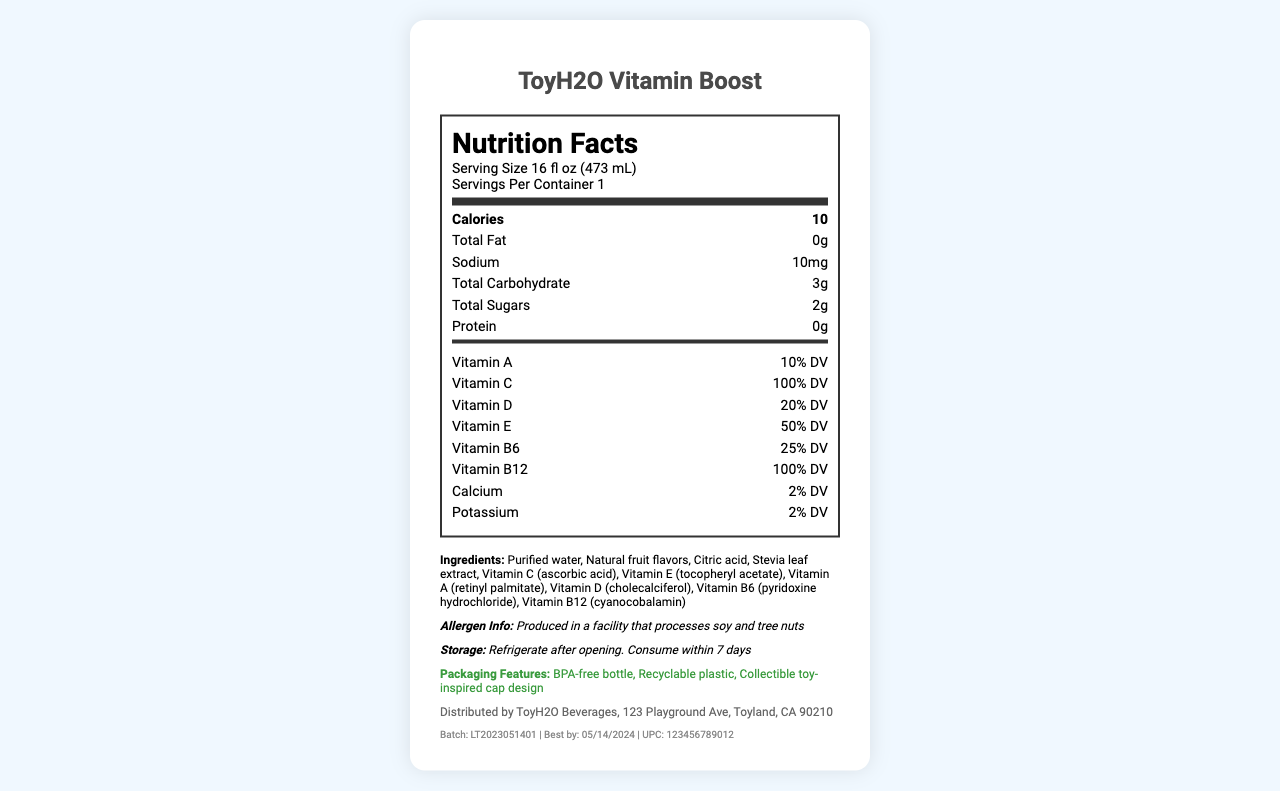What is the serving size of ToyH2O Vitamin Boost? The serving size is explicitly stated as "16 fl oz (473 mL)" under the nutrition facts title.
Answer: 16 fl oz (473 mL) How many calories are there per serving? The nutrition label indicates "Calories 10" for each serving.
Answer: 10 What vitamins and their daily values are included in this water bottle? The vitamins and daily values are listed under the vitamins section of the nutrition label.
Answer: Vitamin A (10% DV), Vitamin C (100% DV), Vitamin D (20% DV), Vitamin E (50% DV), Vitamin B6 (25% DV), Vitamin B12 (100% DV) What should consumers do after opening the bottle? The storage instructions state, "Refrigerate after opening. Consume within 7 days."
Answer: Refrigerate after opening. Consume within 7 days. Is the bottle BPA-free? Under packaging features, it mentions "BPA-free bottle".
Answer: Yes How many grams of protein are there in ToyH2O Vitamin Boost? The nutrition label mentions "Protein 0g".
Answer: 0g Are there any allergens in this product? The allergen info states it is produced in a facility that processes soy and tree nuts, but it does not specify if the product itself contains allergens.
Answer: Cannot be determined Which ingredient is used as a sweetener in this product? A. Stevia leaf extract B. Sugar C. Aspartame D. Sucralose The ingredient list includes "Stevia leaf extract," and no other artificial or sugar-based sweetener is mentioned.
Answer: A. Stevia leaf extract How much sodium is in one serving of ToyH2O Vitamin Boost? The sodium content is listed as "10mg" on the nutrition label.
Answer: 10mg How much total carbohydrate is in one serving? The total carbohydrate listed is "3g".
Answer: 3g What is the expiration date for this product? The expiration date is explicitly stated as "Best by: 05/14/2024".
Answer: Best by: 05/14/2024 Is the packaging recyclable? Under packaging features, it specifies "Recyclable plastic".
Answer: Yes Summarize the information provided on the ToyH2O Vitamin Boost nutrition label. This provides a detailed overview of the product, summarizing its serving size, calorie count, vitamin content, ingredients, allergen information, packaging features, and other essential details.
Answer: ToyH2O Vitamin Boost is a vitamin-fortified water in a 16 fl oz (473 mL) bottle, containing 10 calories per serving. It is fortified with several vitamins including A, C, D, E, B6, and B12, with various daily values. It includes ingredients like purified water and natural fruit flavors, and sweetened with stevia leaf extract. The product contains 0g total fat, 10mg sodium, 3g total carbohydrate, 2g total sugars, and 0g protein. It is produced in a facility that processes soy and tree nuts, is BPA-free, and is packaged in recyclable plastic with a collectible toy-inspired cap. Storage instructions advise refrigerating after opening and consuming within 7 days. The product's expiration date is 05/14/2024. What is the distribution address for ToyH2O Vitamin Boost? The distribution info provided states "Distributed by ToyH2O Beverages, 123 Playground Ave, Toyland, CA 90210."
Answer: 123 Playground Ave, Toyland, CA 90210 Does the product contain any added sugars? The label lists "Total Sugars" but does not specify any "Included Added Sugars," implying there are no added sugars.
Answer: No What is the UPC code for ToyH2O Vitamin Boost? The codes section lists "UPC: 123456789012".
Answer: 123456789012 Does ToyH2O Vitamin Boost contain any gluten? The label does not provide any details about gluten or gluten-containing ingredients.
Answer: Not enough information 